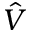Convert formula to latex. <formula><loc_0><loc_0><loc_500><loc_500>\hat { V }</formula> 